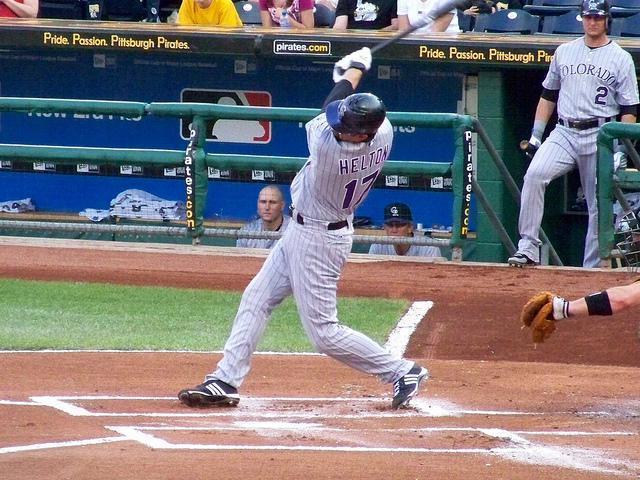Which city is the team in gray from?
Choose the right answer from the provided options to respond to the question.
Options: Oakland, cleveland, colorado, cincinnati. Colorado. 